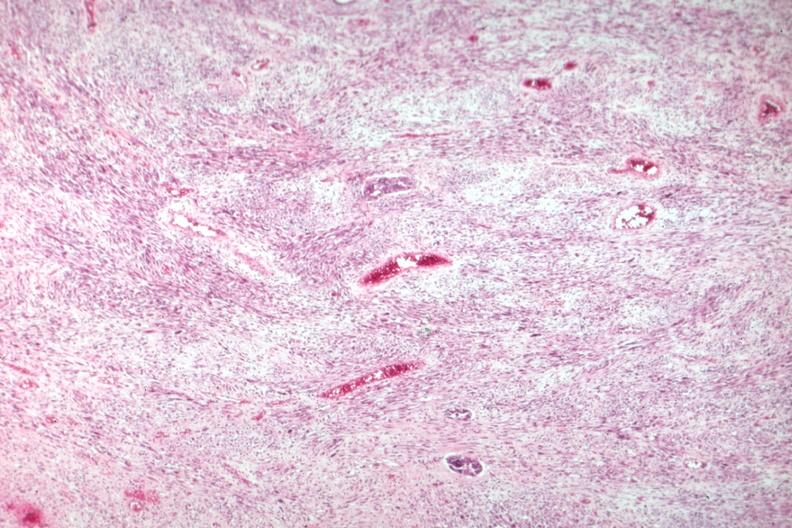s uterus present?
Answer the question using a single word or phrase. Yes 